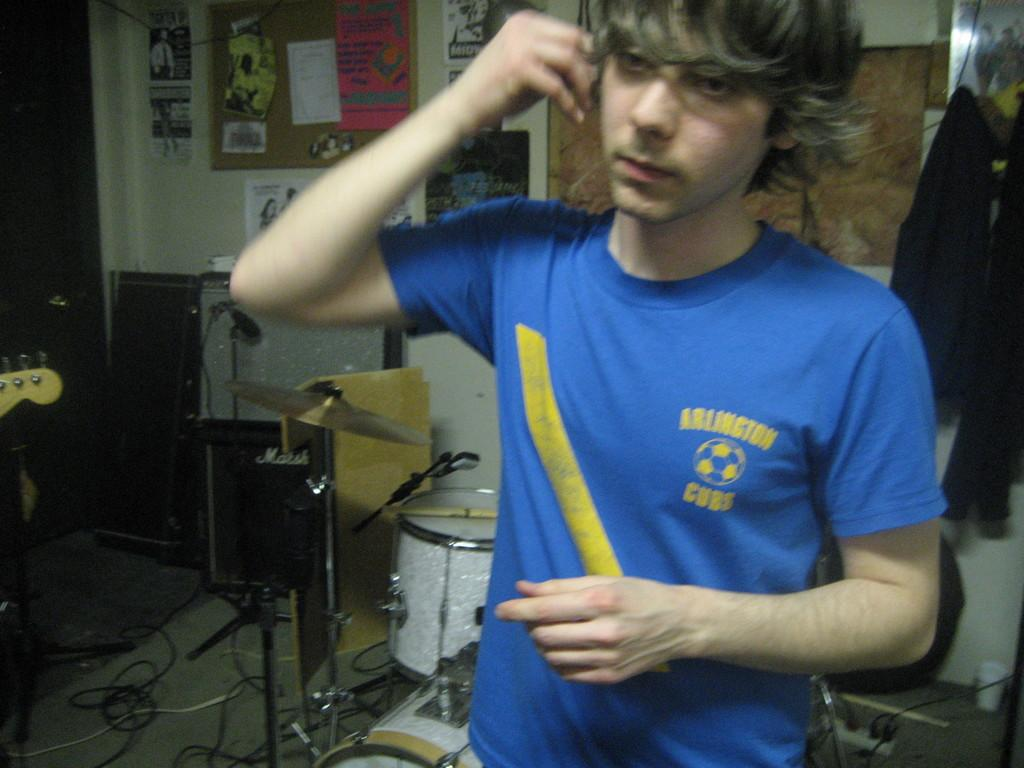<image>
Create a compact narrative representing the image presented. A man is wearing a blue shirt that says Arlington Cubs on the chest. 